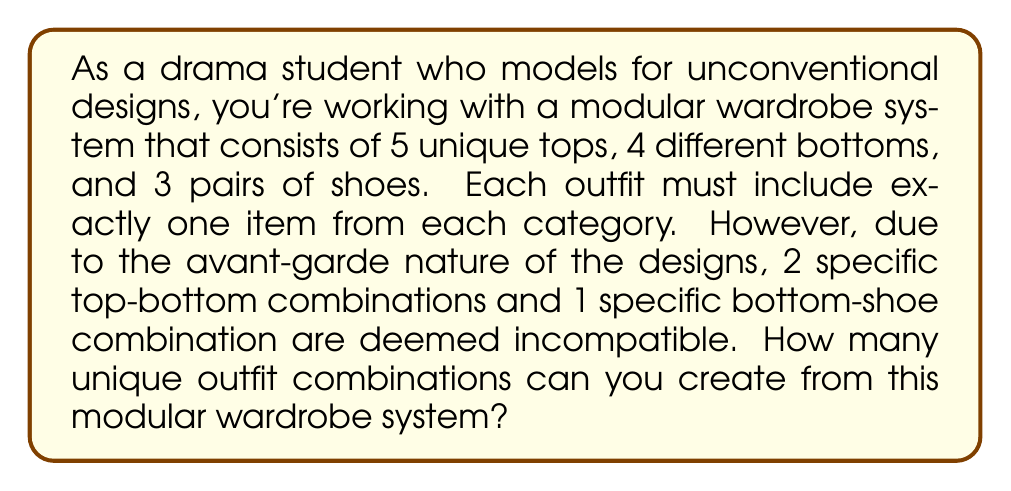Show me your answer to this math problem. Let's approach this problem step-by-step using the principles of Ring theory and the Inclusion-Exclusion Principle:

1) First, we calculate the total number of combinations without restrictions:
   $$5 \text{ tops} \times 4 \text{ bottoms} \times 3 \text{ shoes} = 60 \text{ combinations}$$

2) Now, we need to subtract the incompatible combinations:
   - 2 incompatible top-bottom combinations: Each of these would have been part of 3 outfits (one for each shoe option).
   - 1 incompatible bottom-shoe combination: This would have been part of 5 outfits (one for each top option).

3) However, we need to be careful not to double-count. If an incompatible top-bottom combination coincides with the incompatible bottom-shoe combination, we would have subtracted that outfit twice.

4) To account for this, we use the Inclusion-Exclusion Principle:
   $$|A \cup B| = |A| + |B| - |A \cap B|$$

   Where $A$ is the set of outfits with incompatible top-bottom combinations, and $B$ is the set of outfits with the incompatible bottom-shoe combination.

5) Calculating:
   $$|A| = 2 \times 3 = 6 \text{ outfits}$$
   $$|B| = 5 \text{ outfits}$$
   $$|A \cap B| = 2 \text{ outfits} \text{ (at most, could be 0, 1, or 2)}$$

6) Therefore, the number of incompatible outfits is:
   $$6 + 5 - 2 = 9 \text{ outfits}$$

7) The final number of unique outfit combinations is:
   $$60 - 9 = 51 \text{ combinations}$$
Answer: 51 unique outfit combinations 